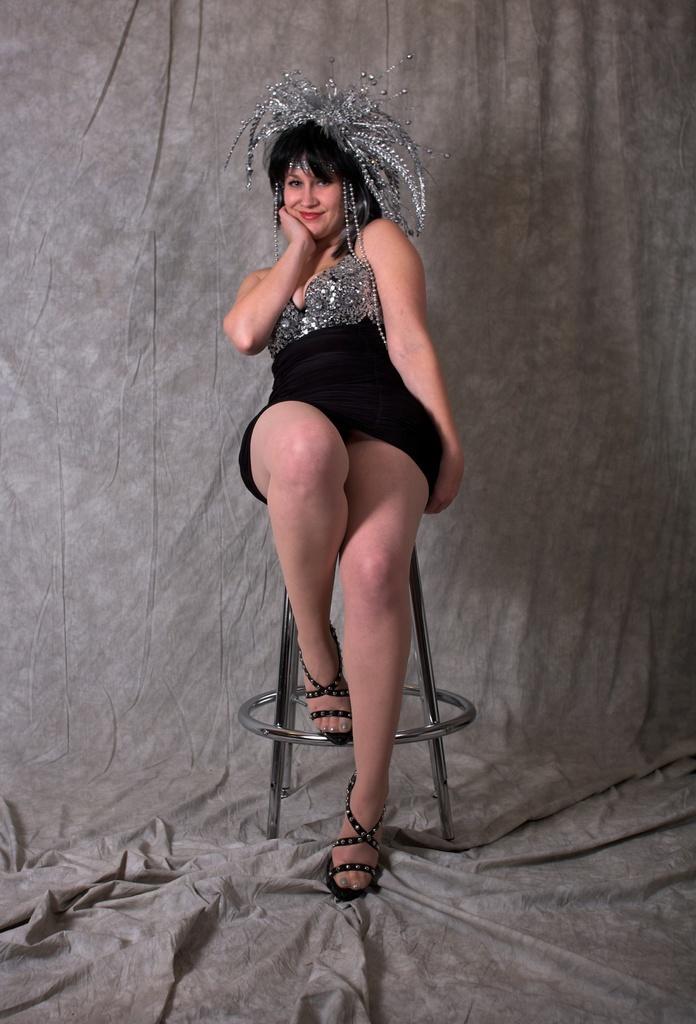Describe this image in one or two sentences. Here I can see a woman wearing black color dress, crown on the head, sitting on a chair, smiling and giving pose for the picture. At the back of her there is a curtain. 